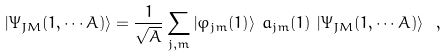Convert formula to latex. <formula><loc_0><loc_0><loc_500><loc_500>\left | \Psi _ { J M } ( 1 , \cdots A ) \right \rangle = \frac { 1 } { \sqrt { A } } \sum _ { j , m } \left | \varphi _ { j m } ( 1 ) \right \rangle \, a _ { j m } ( 1 ) \, \left | \Psi _ { J M } ( 1 , \cdots A ) \right \rangle \ ,</formula> 